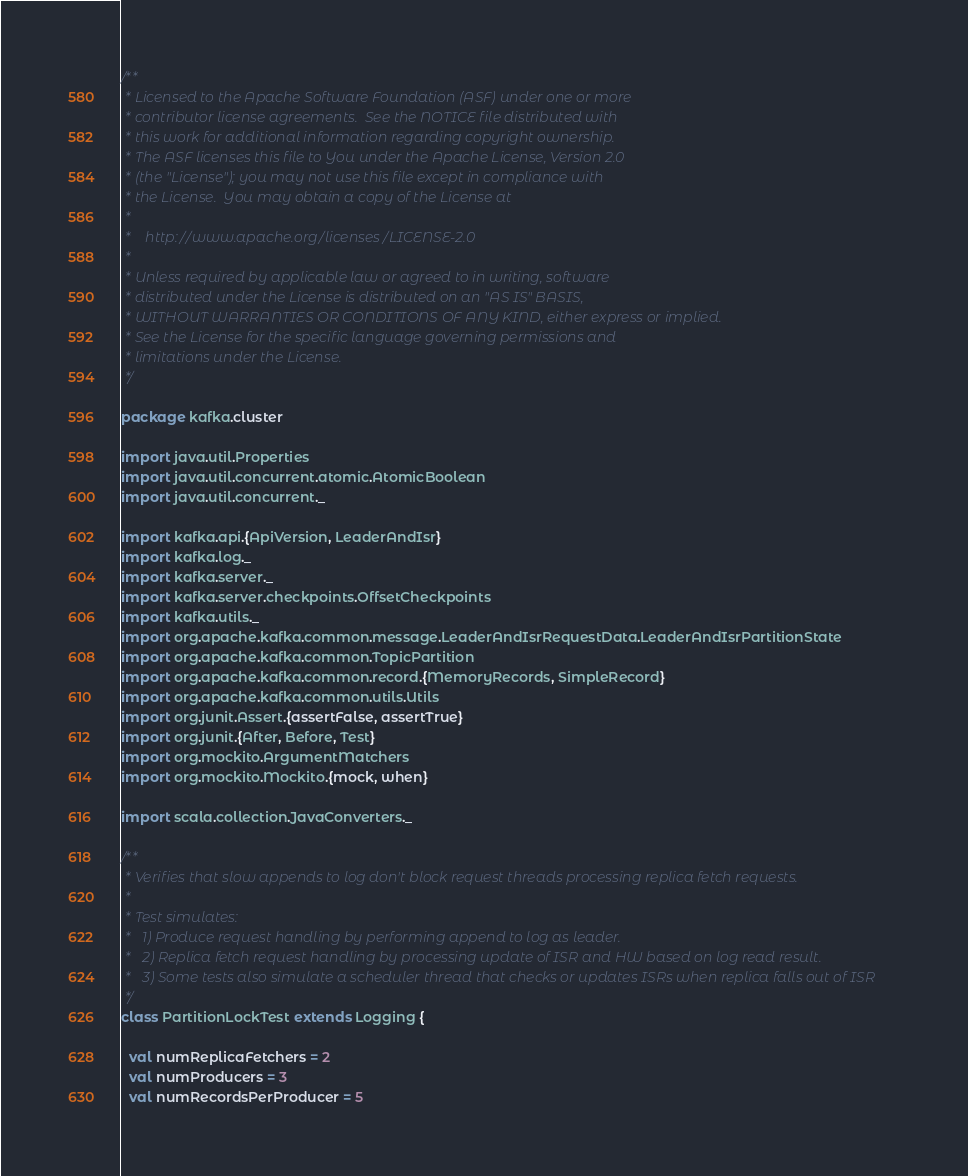Convert code to text. <code><loc_0><loc_0><loc_500><loc_500><_Scala_>/**
 * Licensed to the Apache Software Foundation (ASF) under one or more
 * contributor license agreements.  See the NOTICE file distributed with
 * this work for additional information regarding copyright ownership.
 * The ASF licenses this file to You under the Apache License, Version 2.0
 * (the "License"); you may not use this file except in compliance with
 * the License.  You may obtain a copy of the License at
 *
 *    http://www.apache.org/licenses/LICENSE-2.0
 *
 * Unless required by applicable law or agreed to in writing, software
 * distributed under the License is distributed on an "AS IS" BASIS,
 * WITHOUT WARRANTIES OR CONDITIONS OF ANY KIND, either express or implied.
 * See the License for the specific language governing permissions and
 * limitations under the License.
 */

package kafka.cluster

import java.util.Properties
import java.util.concurrent.atomic.AtomicBoolean
import java.util.concurrent._

import kafka.api.{ApiVersion, LeaderAndIsr}
import kafka.log._
import kafka.server._
import kafka.server.checkpoints.OffsetCheckpoints
import kafka.utils._
import org.apache.kafka.common.message.LeaderAndIsrRequestData.LeaderAndIsrPartitionState
import org.apache.kafka.common.TopicPartition
import org.apache.kafka.common.record.{MemoryRecords, SimpleRecord}
import org.apache.kafka.common.utils.Utils
import org.junit.Assert.{assertFalse, assertTrue}
import org.junit.{After, Before, Test}
import org.mockito.ArgumentMatchers
import org.mockito.Mockito.{mock, when}

import scala.collection.JavaConverters._

/**
 * Verifies that slow appends to log don't block request threads processing replica fetch requests.
 *
 * Test simulates:
 *   1) Produce request handling by performing append to log as leader.
 *   2) Replica fetch request handling by processing update of ISR and HW based on log read result.
 *   3) Some tests also simulate a scheduler thread that checks or updates ISRs when replica falls out of ISR
 */
class PartitionLockTest extends Logging {

  val numReplicaFetchers = 2
  val numProducers = 3
  val numRecordsPerProducer = 5
</code> 